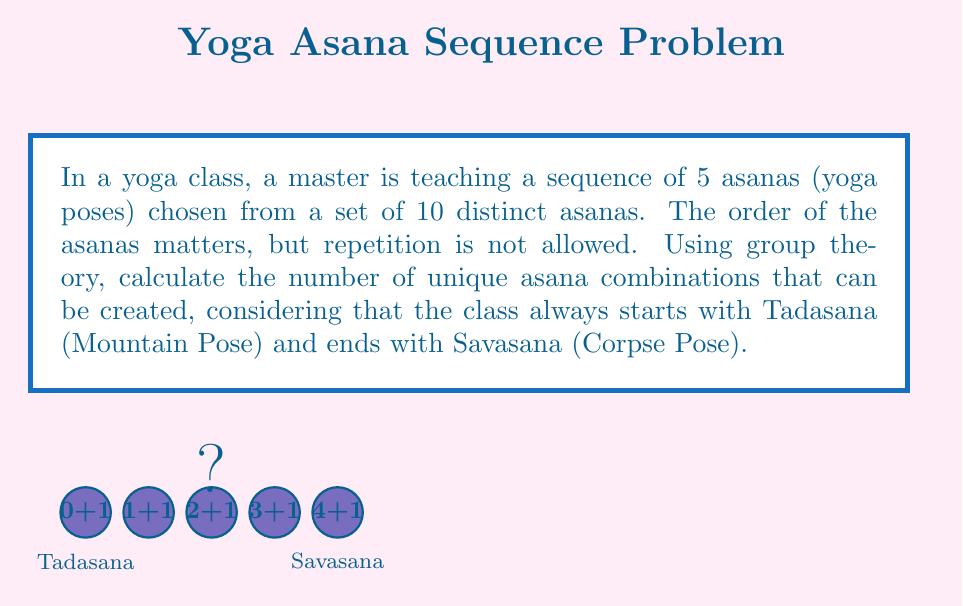Can you solve this math problem? Let's approach this step-by-step using group theory concepts:

1) We start with a set of 10 distinct asanas. This forms our initial set $S$ with $|S| = 10$.

2) The sequence always starts with Tadasana and ends with Savasana. This means we only need to choose 3 asanas for the middle positions.

3) We can consider this as a permutation problem where we're selecting 3 asanas from the remaining 8 (10 - 2 = 8, as Tadasana and Savasana are fixed).

4) In group theory, this is equivalent to finding the order of a subgroup of the symmetric group $S_8$ where we're choosing 3-element permutations.

5) The number of such permutations is given by the falling factorial:

   $$(8)_3 = 8 \cdot 7 \cdot 6$$

6) This can be calculated as:

   $$8 \cdot 7 \cdot 6 = 336$$

7) Therefore, there are 336 unique ways to arrange 3 asanas in the middle positions.

8) Since the first and last positions are fixed, this is also the total number of unique asana combinations for the entire sequence.
Answer: 336 